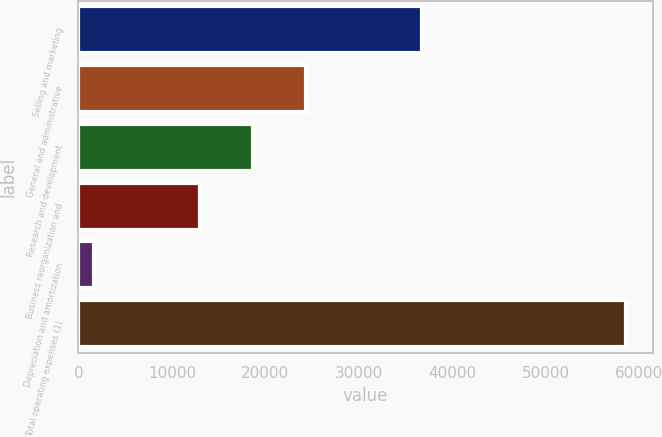Convert chart to OTSL. <chart><loc_0><loc_0><loc_500><loc_500><bar_chart><fcel>Selling and marketing<fcel>General and administrative<fcel>Research and development<fcel>Business reorganization and<fcel>Depreciation and amortization<fcel>Total operating expenses (1)<nl><fcel>36728<fcel>24355.6<fcel>18672.3<fcel>12989<fcel>1694<fcel>58527<nl></chart> 